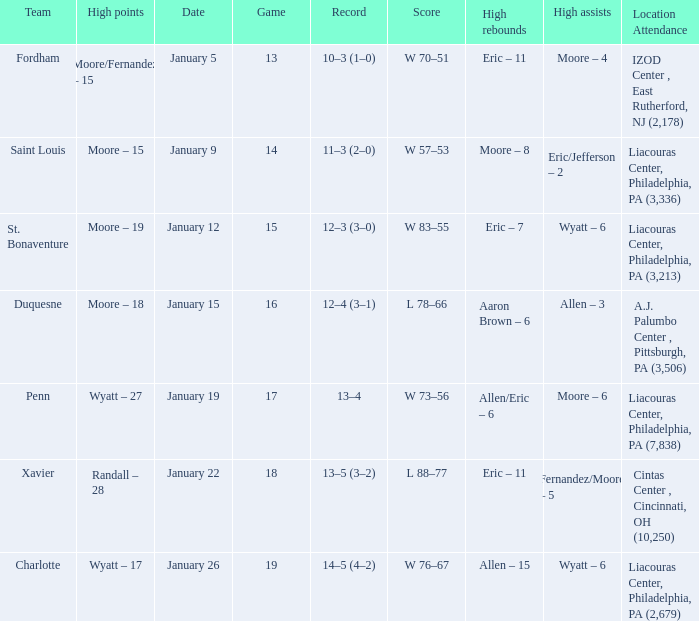Could you parse the entire table? {'header': ['Team', 'High points', 'Date', 'Game', 'Record', 'Score', 'High rebounds', 'High assists', 'Location Attendance'], 'rows': [['Fordham', 'Moore/Fernandez – 15', 'January 5', '13', '10–3 (1–0)', 'W 70–51', 'Eric – 11', 'Moore – 4', 'IZOD Center , East Rutherford, NJ (2,178)'], ['Saint Louis', 'Moore – 15', 'January 9', '14', '11–3 (2–0)', 'W 57–53', 'Moore – 8', 'Eric/Jefferson – 2', 'Liacouras Center, Philadelphia, PA (3,336)'], ['St. Bonaventure', 'Moore – 19', 'January 12', '15', '12–3 (3–0)', 'W 83–55', 'Eric – 7', 'Wyatt – 6', 'Liacouras Center, Philadelphia, PA (3,213)'], ['Duquesne', 'Moore – 18', 'January 15', '16', '12–4 (3–1)', 'L 78–66', 'Aaron Brown – 6', 'Allen – 3', 'A.J. Palumbo Center , Pittsburgh, PA (3,506)'], ['Penn', 'Wyatt – 27', 'January 19', '17', '13–4', 'W 73–56', 'Allen/Eric – 6', 'Moore – 6', 'Liacouras Center, Philadelphia, PA (7,838)'], ['Xavier', 'Randall – 28', 'January 22', '18', '13–5 (3–2)', 'L 88–77', 'Eric – 11', 'Fernandez/Moore – 5', 'Cintas Center , Cincinnati, OH (10,250)'], ['Charlotte', 'Wyatt – 17', 'January 26', '19', '14–5 (4–2)', 'W 76–67', 'Allen – 15', 'Wyatt – 6', 'Liacouras Center, Philadelphia, PA (2,679)']]} Who had the most assists and how many did they have on January 5? Moore – 4. 